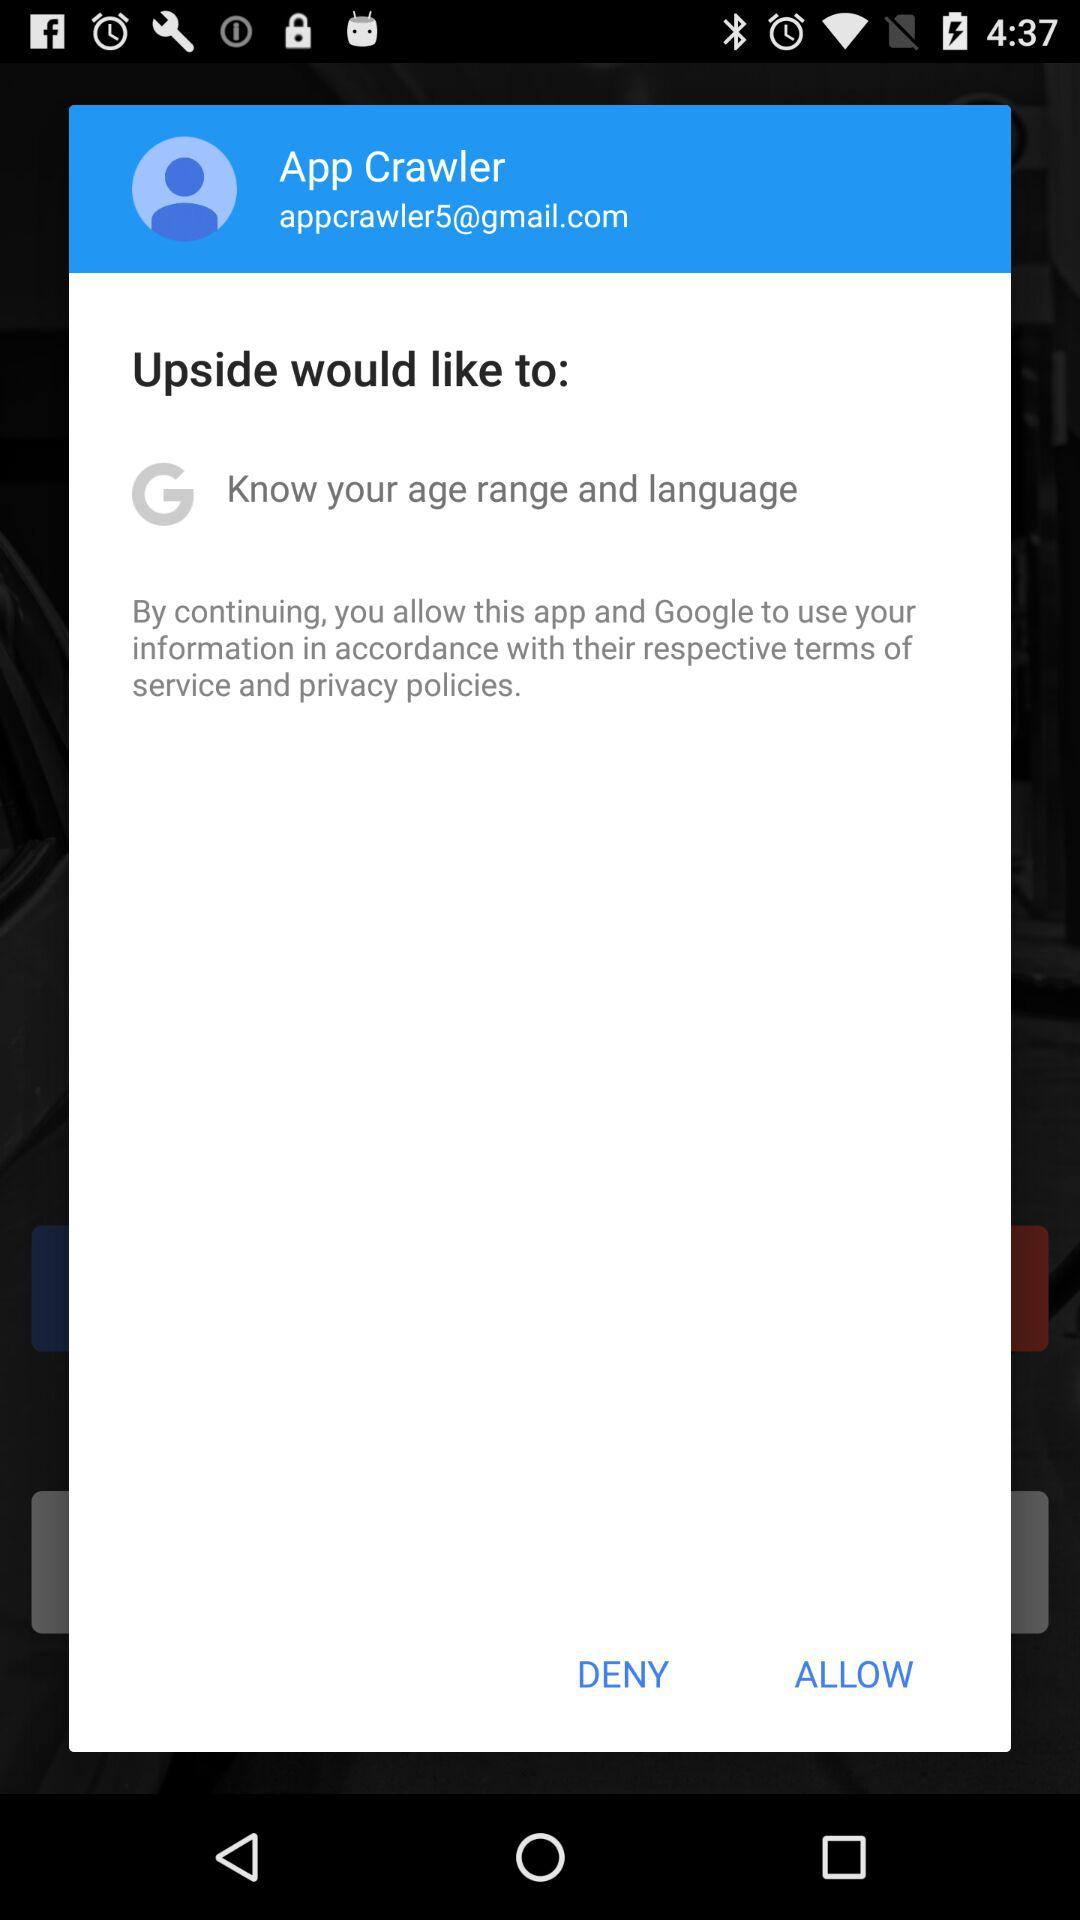What is the name of the user? The name of the user is App Crawler. 